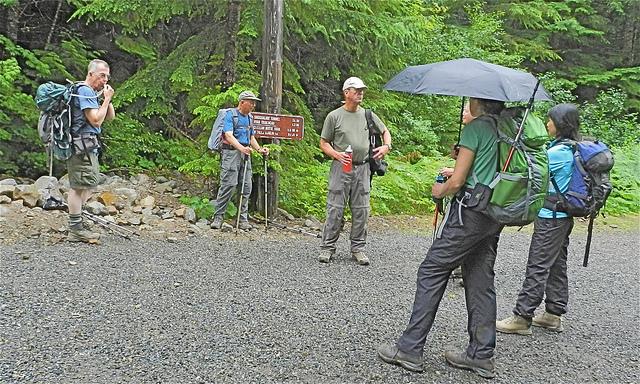What activity is the group participating in?
Be succinct. Hiking. Do a lot of trains pass through here?
Quick response, please. No. How many people?
Answer briefly. 5. 